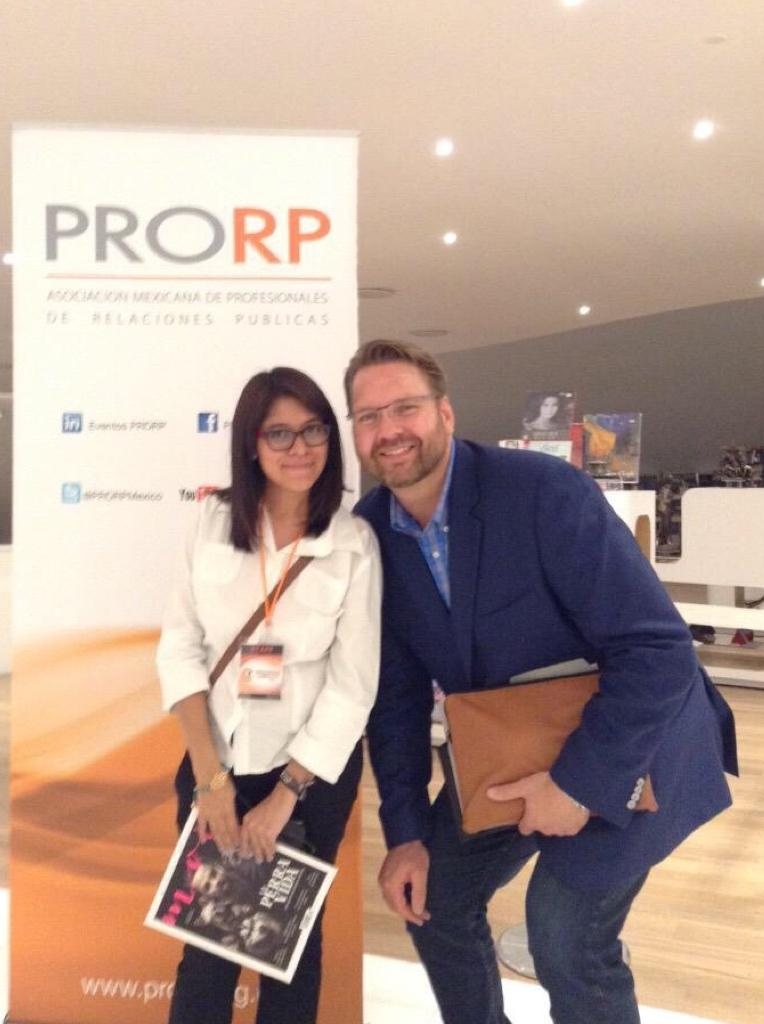How many people are in the image? There are two persons in the image. What are the persons doing in the image? The persons are standing and smiling. What objects are the persons holding in the image? The persons are holding books. What can be seen in the background of the image? There are boards and lights in the background of the image. What type of apples are being used as a form of currency in the image? There are no apples or currency present in the image; the persons are holding books and standing in front of boards and lights. 